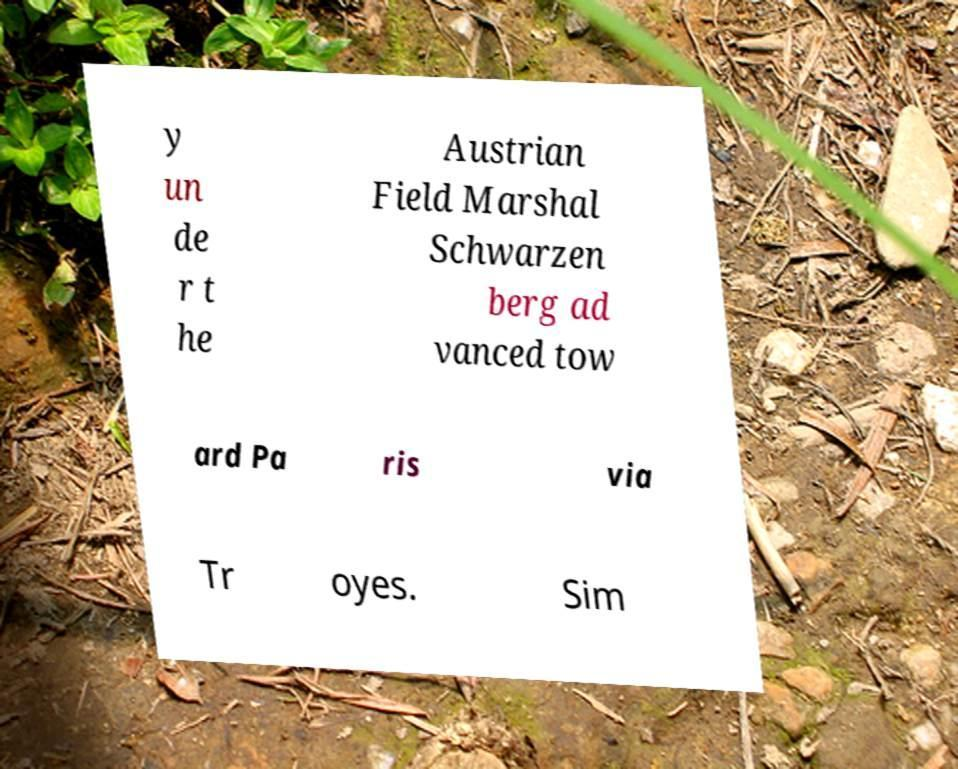Could you assist in decoding the text presented in this image and type it out clearly? y un de r t he Austrian Field Marshal Schwarzen berg ad vanced tow ard Pa ris via Tr oyes. Sim 